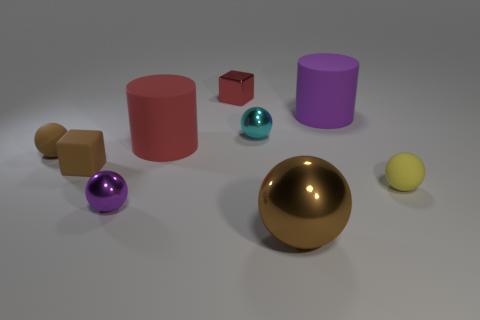Subtract all small brown spheres. How many spheres are left? 4 Subtract all yellow spheres. How many spheres are left? 4 Subtract all red balls. Subtract all yellow cubes. How many balls are left? 5 Add 1 big yellow shiny blocks. How many objects exist? 10 Subtract all blocks. How many objects are left? 7 Add 6 tiny purple things. How many tiny purple things are left? 7 Add 5 big brown things. How many big brown things exist? 6 Subtract 0 cyan blocks. How many objects are left? 9 Subtract all large gray rubber balls. Subtract all small purple shiny things. How many objects are left? 8 